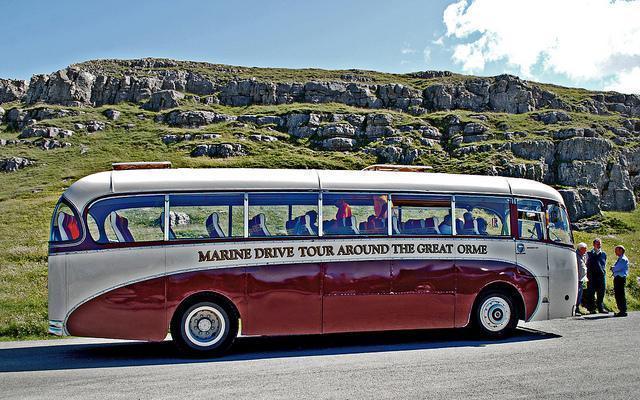What is the bus primarily used for?
Answer the question by selecting the correct answer among the 4 following choices.
Options: Mail delivery, school transportation, racing, tours. Tours. 